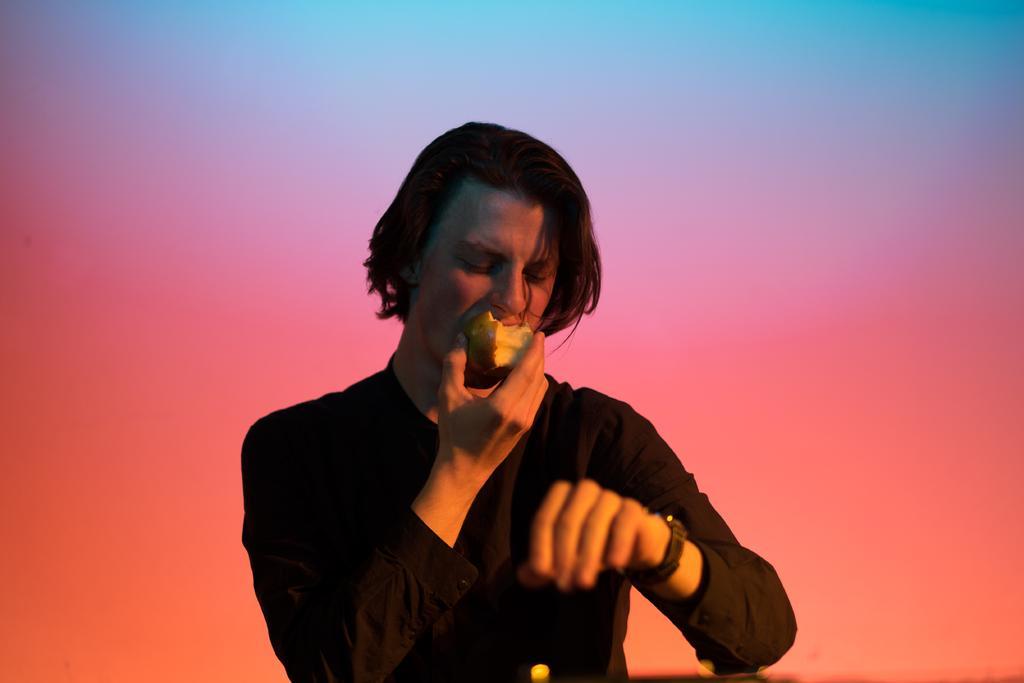Please provide a concise description of this image. In the center of the image, we can see a person holding an apple. 